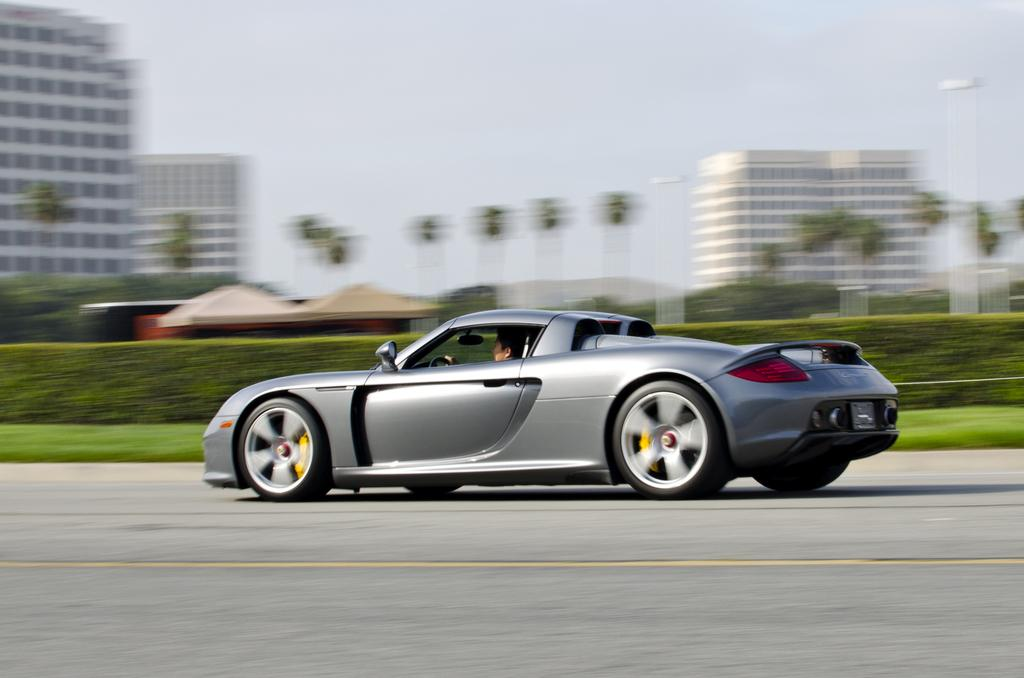What is the main subject of the image? The main subject of the image is a car on the road. Can you describe the car's occupant? A person is inside the car. What type of vegetation can be seen in the image? There is grass visible in the image, as well as trees. What structures are present in the image? There are sheds and buildings visible in the image. What is visible in the background of the image? The sky is visible in the background of the image, along with buildings. How would you describe the image's quality? The image is blurry. How many pears are on the roof of the car in the image? There are no pears visible on the roof of the car in the image. What type of eggs can be seen in the image? There are no eggs present in the image. 